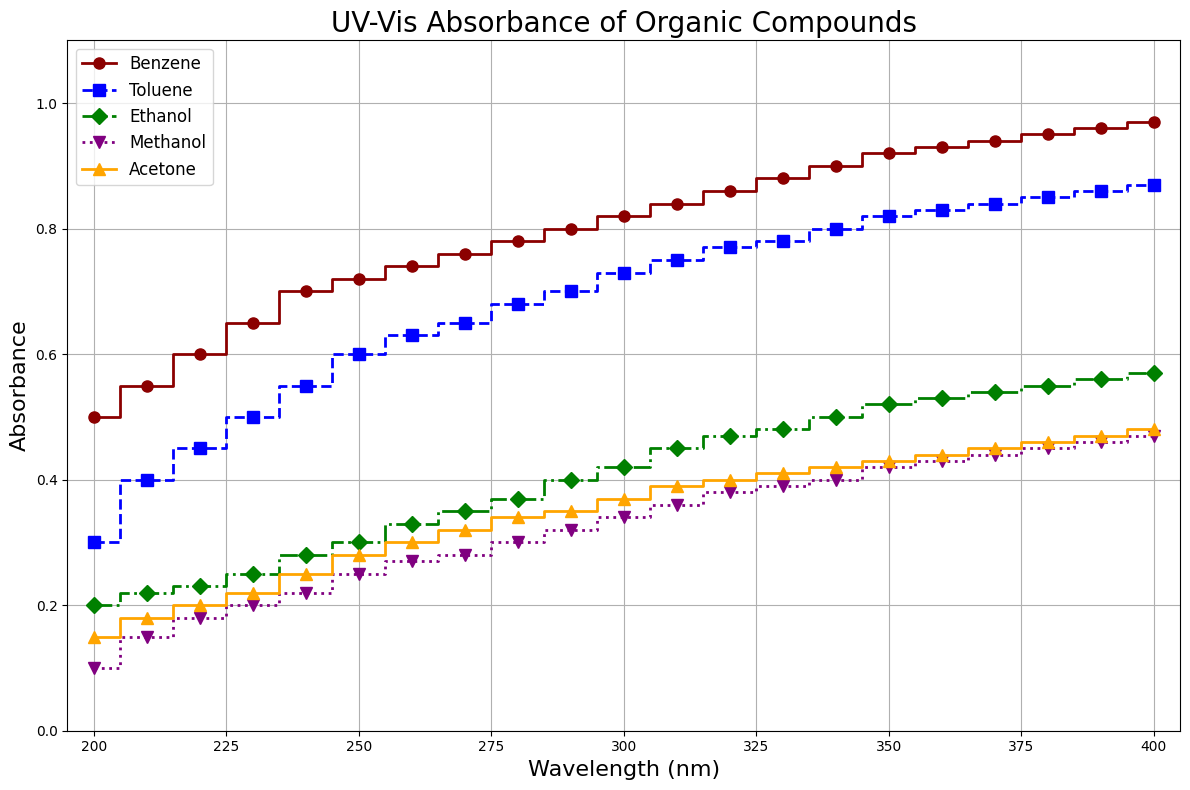what is the highest absorbance value recorded for Benzene? To find the highest absorbance value for Benzene, look at the plot, find the line corresponding to Benzene (indicated as a dark red line with circles), and identify its peak value. The highest absorbance value for Benzene is 0.97.
Answer: 0.97 at a wavelength of 250 nm, which compound has the highest absorbance? At the 250 nm mark on the x-axis, observe the corresponding absorbance levels for each compound. Benzene has the highest value at this point, which is 0.72.
Answer: Benzene what is the difference in absorbance between Toluene and Methanol at 350 nm? At 350 nm, find the absorbance values for Toluene and Methanol from the plot (Toluene: 0.82, Methanol: 0.42). Subtract Methanol's value from Toluene's value: 0.82 - 0.42 = 0.40.
Answer: 0.40 which compound shows the steepest increase in absorbance between 200 nm and 250 nm? Observe the slopes of the lines between 200 nm and 250 nm for each compound. Benzene shows the steepest increase (0.72-0.50=0.22), while others have smaller increases.
Answer: Benzene what is the average absorbance of Acetone from 200 nm to 400 nm? Sum all the absorbance values for Acetone and divide by the number of data points. Sum = 0.15 + 0.18 + 0.20 + 0.22 + 0.25 + 0.28 + 0.30 + 0.32 + 0.34 + 0.35 + 0.37 + 0.39 + 0.40 + 0.41 + 0.42 + 0.43 + 0.44 + 0.45 + 0.46 + 0.47 = 6.27. Average = 6.27 / 20 = 0.3135.
Answer: 0.3135 